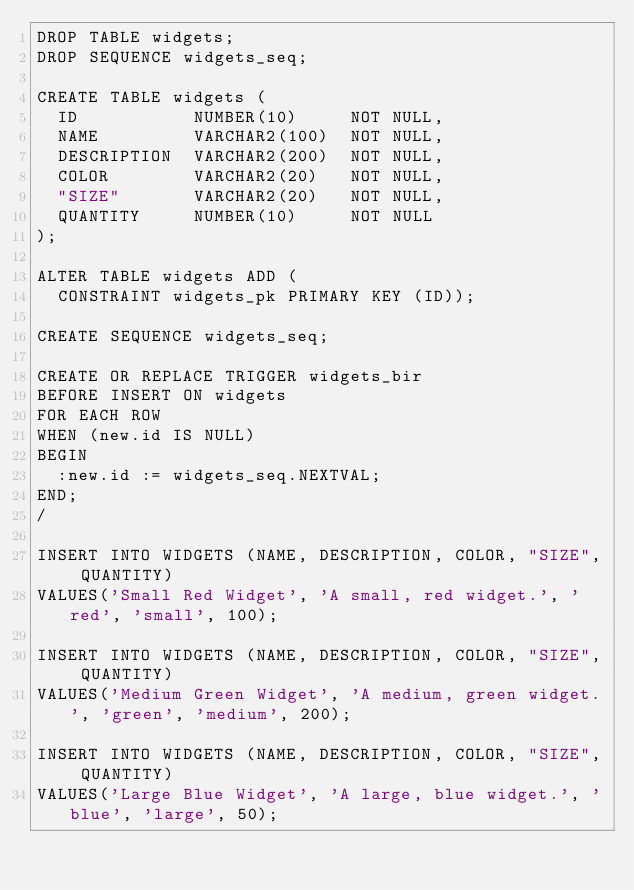<code> <loc_0><loc_0><loc_500><loc_500><_SQL_>DROP TABLE widgets;
DROP SEQUENCE widgets_seq;

CREATE TABLE widgets (
  ID           NUMBER(10)     NOT NULL,
  NAME         VARCHAR2(100)  NOT NULL,
  DESCRIPTION  VARCHAR2(200)  NOT NULL,
  COLOR        VARCHAR2(20)   NOT NULL,
  "SIZE"       VARCHAR2(20)   NOT NULL,
  QUANTITY     NUMBER(10)     NOT NULL
);

ALTER TABLE widgets ADD (
  CONSTRAINT widgets_pk PRIMARY KEY (ID));

CREATE SEQUENCE widgets_seq;

CREATE OR REPLACE TRIGGER widgets_bir
BEFORE INSERT ON widgets
FOR EACH ROW
WHEN (new.id IS NULL)
BEGIN
  :new.id := widgets_seq.NEXTVAL;
END;
/

INSERT INTO WIDGETS (NAME, DESCRIPTION, COLOR, "SIZE", QUANTITY)
VALUES('Small Red Widget', 'A small, red widget.', 'red', 'small', 100);

INSERT INTO WIDGETS (NAME, DESCRIPTION, COLOR, "SIZE", QUANTITY)
VALUES('Medium Green Widget', 'A medium, green widget.', 'green', 'medium', 200);

INSERT INTO WIDGETS (NAME, DESCRIPTION, COLOR, "SIZE", QUANTITY)
VALUES('Large Blue Widget', 'A large, blue widget.', 'blue', 'large', 50);
</code> 